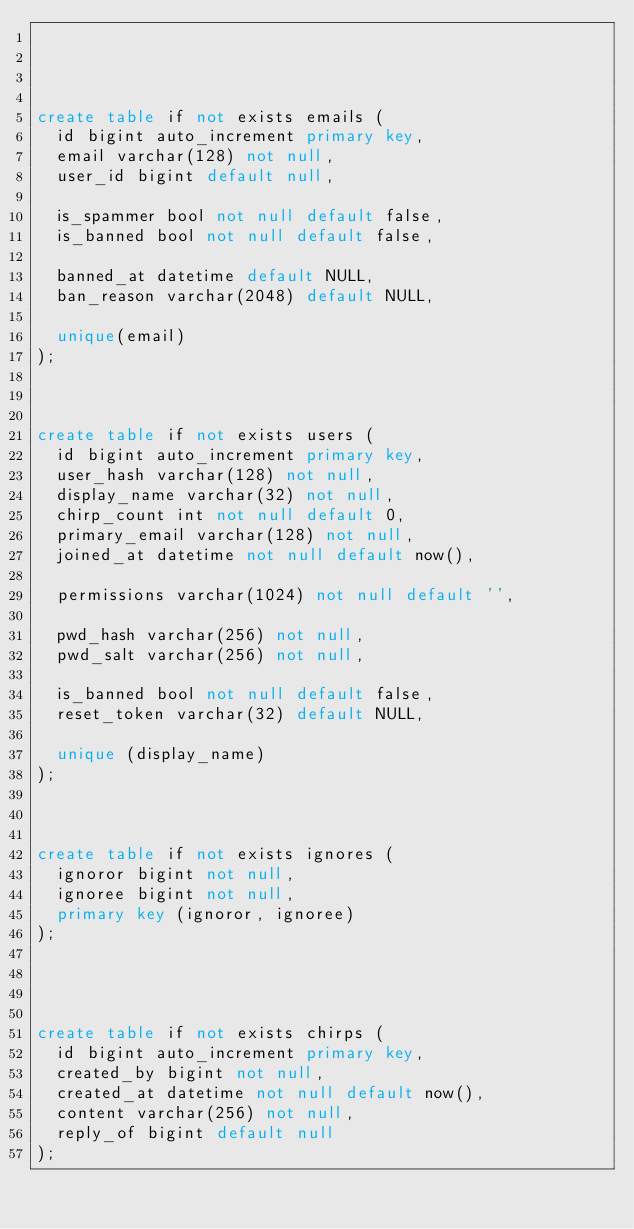<code> <loc_0><loc_0><loc_500><loc_500><_SQL_>



create table if not exists emails (
	id bigint auto_increment primary key,
	email varchar(128) not null,
	user_id bigint default null,
	
	is_spammer bool not null default false,
	is_banned bool not null default false,
	
	banned_at datetime default NULL,
	ban_reason varchar(2048) default NULL,
	
	unique(email)
);



create table if not exists users (
	id bigint auto_increment primary key,
	user_hash varchar(128) not null,
	display_name varchar(32) not null,
	chirp_count int not null default 0,
	primary_email varchar(128) not null,
	joined_at datetime not null default now(),
	
	permissions varchar(1024) not null default '',
	
	pwd_hash varchar(256) not null,
	pwd_salt varchar(256) not null,
	
	is_banned bool not null default false,
	reset_token varchar(32) default NULL,
	
	unique (display_name)
);



create table if not exists ignores (
	ignoror bigint not null,
	ignoree bigint not null,
	primary key (ignoror, ignoree)
);




create table if not exists chirps (
	id bigint auto_increment primary key,
	created_by bigint not null,
	created_at datetime not null default now(),
	content varchar(256) not null,
	reply_of bigint default null
);


</code> 